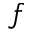Convert formula to latex. <formula><loc_0><loc_0><loc_500><loc_500>f</formula> 